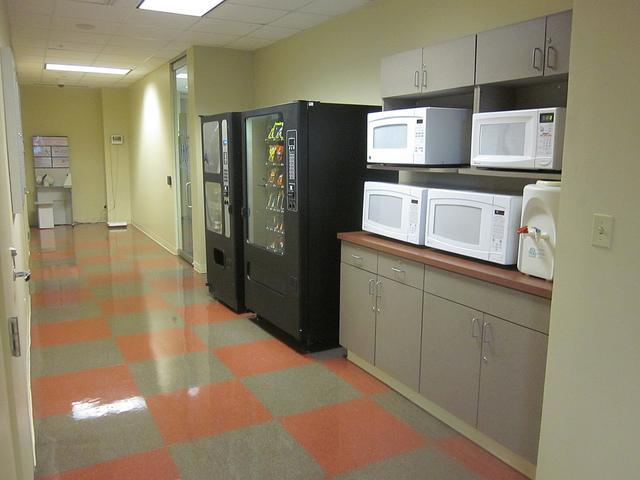How many people can cook food here at once?

Choices:
A) four
B) two
C) one
D) six four 